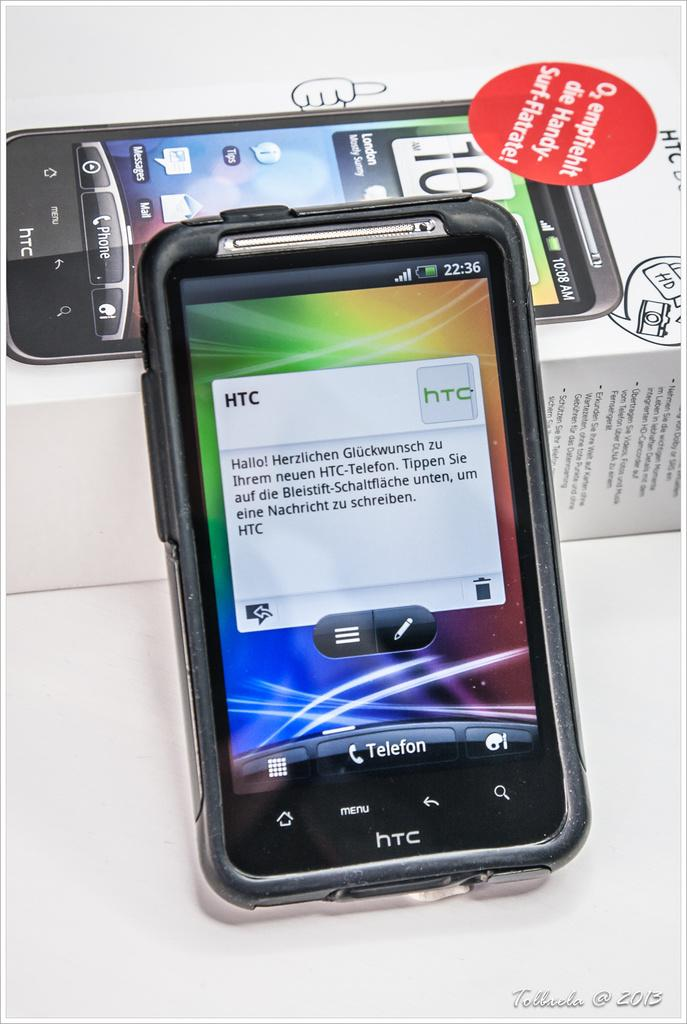Provide a one-sentence caption for the provided image. A HTC smartphone with German text box on the screen is leaning on its box. 